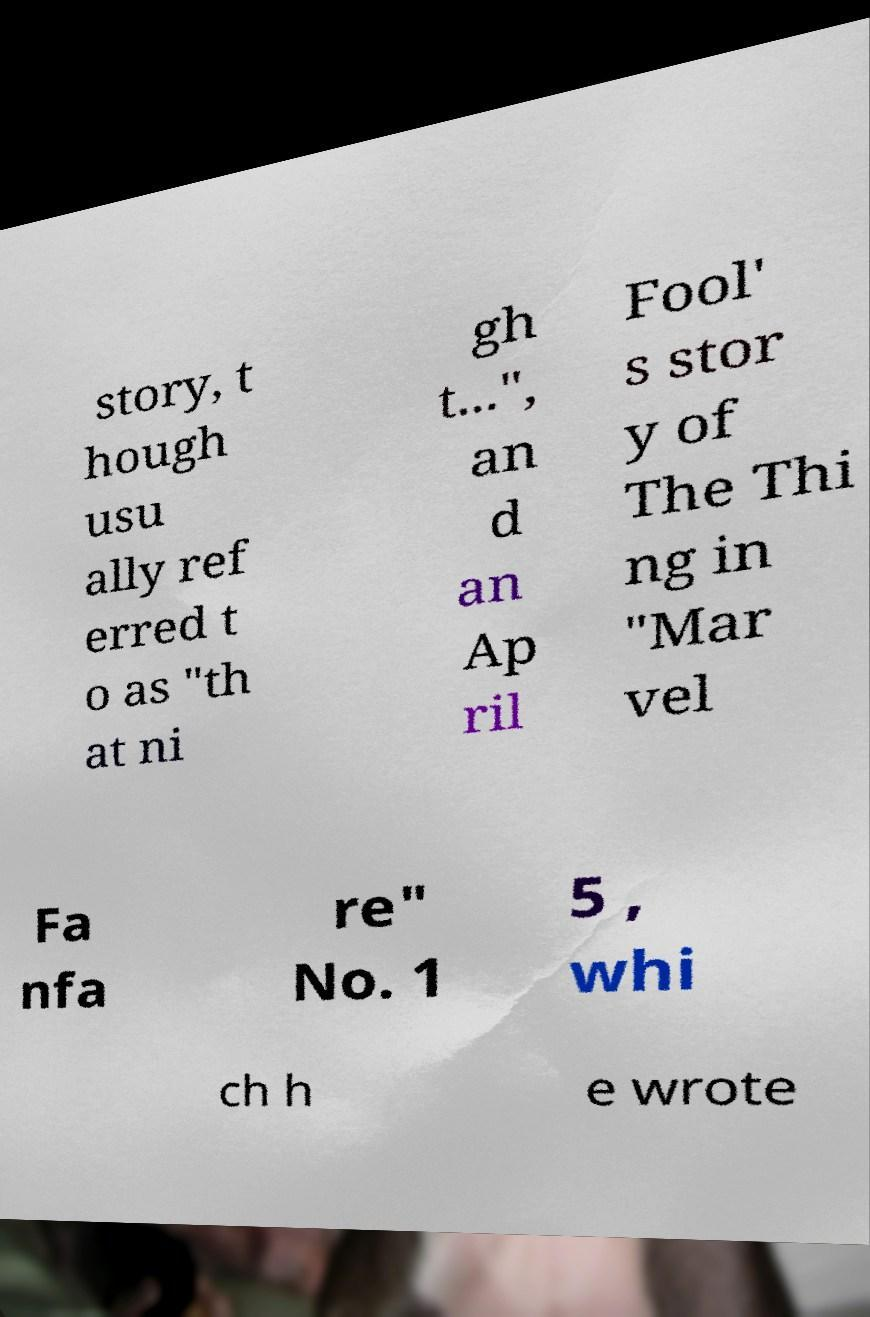What messages or text are displayed in this image? I need them in a readable, typed format. story, t hough usu ally ref erred t o as "th at ni gh t...", an d an Ap ril Fool' s stor y of The Thi ng in "Mar vel Fa nfa re" No. 1 5 , whi ch h e wrote 